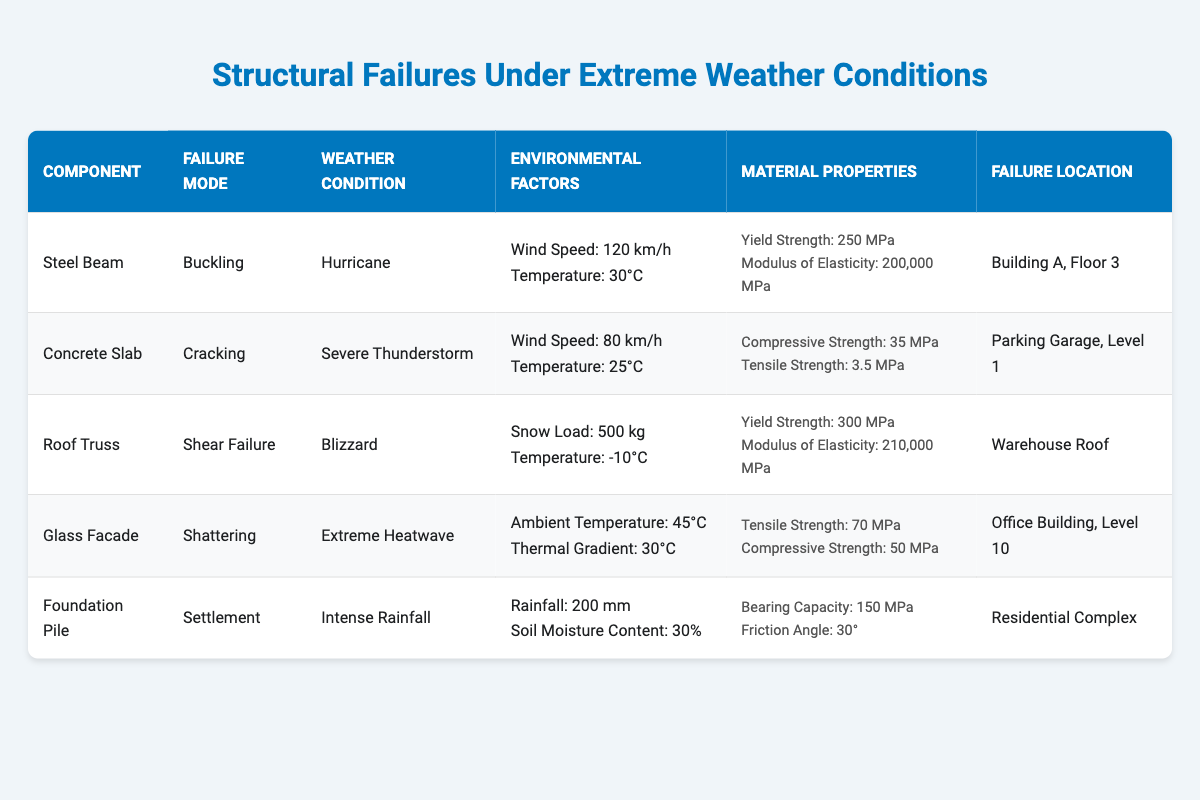What component experienced buckling during a hurricane? The table lists various failures along with their corresponding components. By scanning the "Component" column for the entry associated with the failure mode "Buckling" and "Weather Condition" as "Hurricane", we find that the Steel Beam is the relevant component.
Answer: Steel Beam Which weather condition caused shattering of the glass facade? In the table, under the "Failure Mode" column, we look for "Shattering" and find that it is linked to the "Weather Condition" of "Extreme Heatwave". Thus, the relevant weather condition causing this failure is noted.
Answer: Extreme Heatwave What is the yield strength of the roof truss? To find the yield strength of the Roof Truss, we can look in the "Material Properties" column for the row that lists "Roof Truss". The yield strength mentioned there is 300 MPa.
Answer: 300 MPa Is there any component that failed during severe thunderstorm conditions? By examining the "Weather Condition" column, we can determine that the Concrete Slab was the only component listed with a failure during "Severe Thunderstorm", making this a true statement.
Answer: Yes What is the average wind speed of the failures listed for wind-related conditions? First, we identify all rows where the "Weather Condition" is wind-related: Hurricane (120 km/h) and Severe Thunderstorm (80 km/h). We sum these wind speeds: 120 + 80 = 200 km/h. To find the average, we divide by the number of entries, which is 2: 200/2 = 100 km/h.
Answer: 100 km/h Which failure mode occurred at the parking garage? The table lists a failure mode associated with the "Parking Garage, Level 1" location. By looking at that specific entry in the table, we see that the failure mode is "Cracking".
Answer: Cracking What is the snowfall load associated with the roof truss failure? In the row under "Roof Truss", we find that the failure due to "Shear Failure" occurred under "Blizzard" conditions with a "Snow Load" recorded as 500 kg. Therefore, the snowfall load is noted.
Answer: 500 kg Was the foundation pile's failure due to heavy rain? The "Weather Condition" associated with the Foundation Pile indicates "Intense Rainfall". Checking the relevant entry confirms that this is indeed the case.
Answer: Yes What two factors contributed to the failure of the steel beam? For the Steel Beam, the failure mode is "Buckling" under hurricane conditions, which was affected by a wind speed of 120 km/h and a temperature of 30°C, as detailed in the corresponding columns.
Answer: Wind Speed: 120 km/h, Temperature: 30°C 